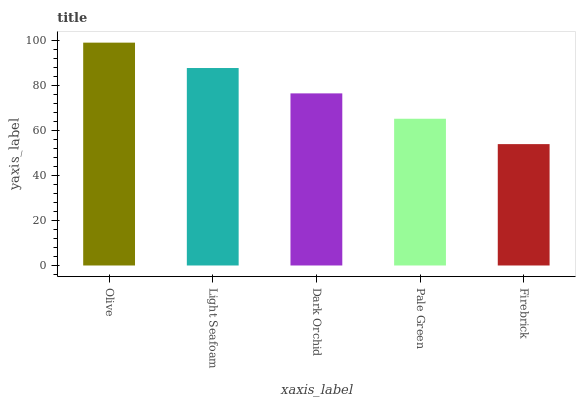Is Firebrick the minimum?
Answer yes or no. Yes. Is Olive the maximum?
Answer yes or no. Yes. Is Light Seafoam the minimum?
Answer yes or no. No. Is Light Seafoam the maximum?
Answer yes or no. No. Is Olive greater than Light Seafoam?
Answer yes or no. Yes. Is Light Seafoam less than Olive?
Answer yes or no. Yes. Is Light Seafoam greater than Olive?
Answer yes or no. No. Is Olive less than Light Seafoam?
Answer yes or no. No. Is Dark Orchid the high median?
Answer yes or no. Yes. Is Dark Orchid the low median?
Answer yes or no. Yes. Is Firebrick the high median?
Answer yes or no. No. Is Pale Green the low median?
Answer yes or no. No. 